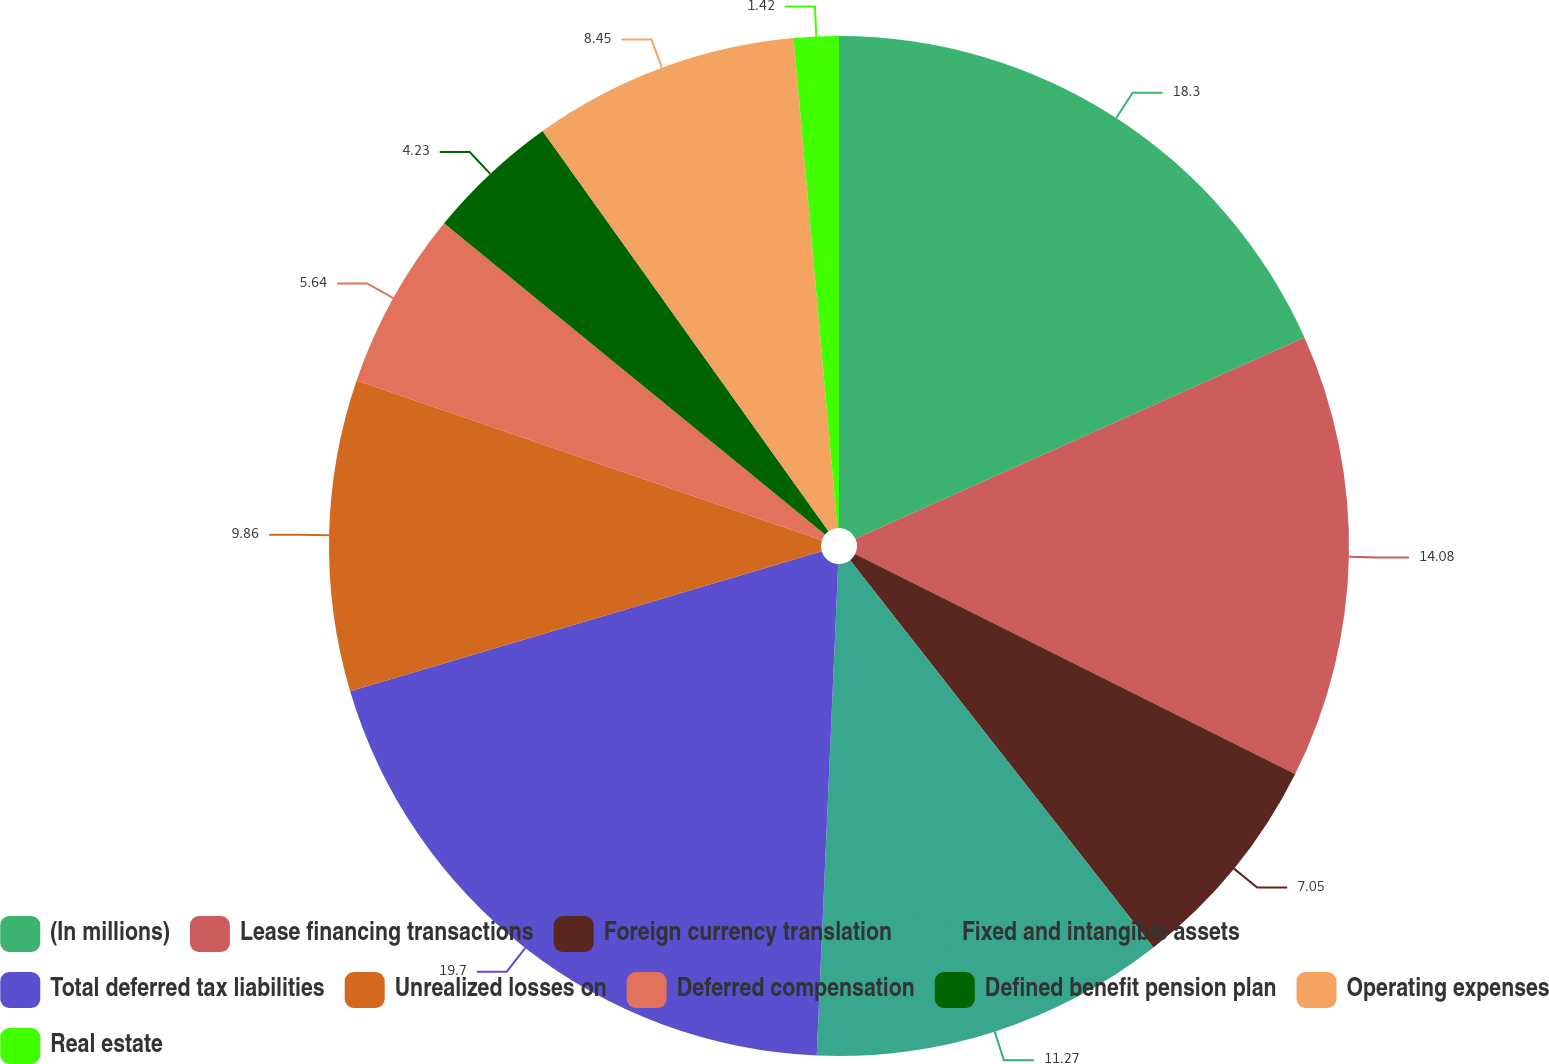Convert chart to OTSL. <chart><loc_0><loc_0><loc_500><loc_500><pie_chart><fcel>(In millions)<fcel>Lease financing transactions<fcel>Foreign currency translation<fcel>Fixed and intangible assets<fcel>Total deferred tax liabilities<fcel>Unrealized losses on<fcel>Deferred compensation<fcel>Defined benefit pension plan<fcel>Operating expenses<fcel>Real estate<nl><fcel>18.3%<fcel>14.08%<fcel>7.05%<fcel>11.27%<fcel>19.71%<fcel>9.86%<fcel>5.64%<fcel>4.23%<fcel>8.45%<fcel>1.42%<nl></chart> 